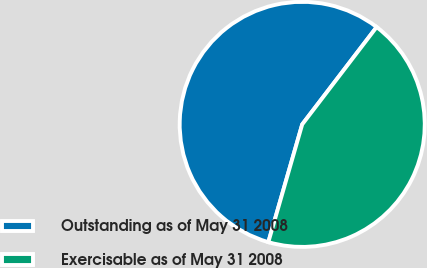<chart> <loc_0><loc_0><loc_500><loc_500><pie_chart><fcel>Outstanding as of May 31 2008<fcel>Exercisable as of May 31 2008<nl><fcel>55.93%<fcel>44.07%<nl></chart> 